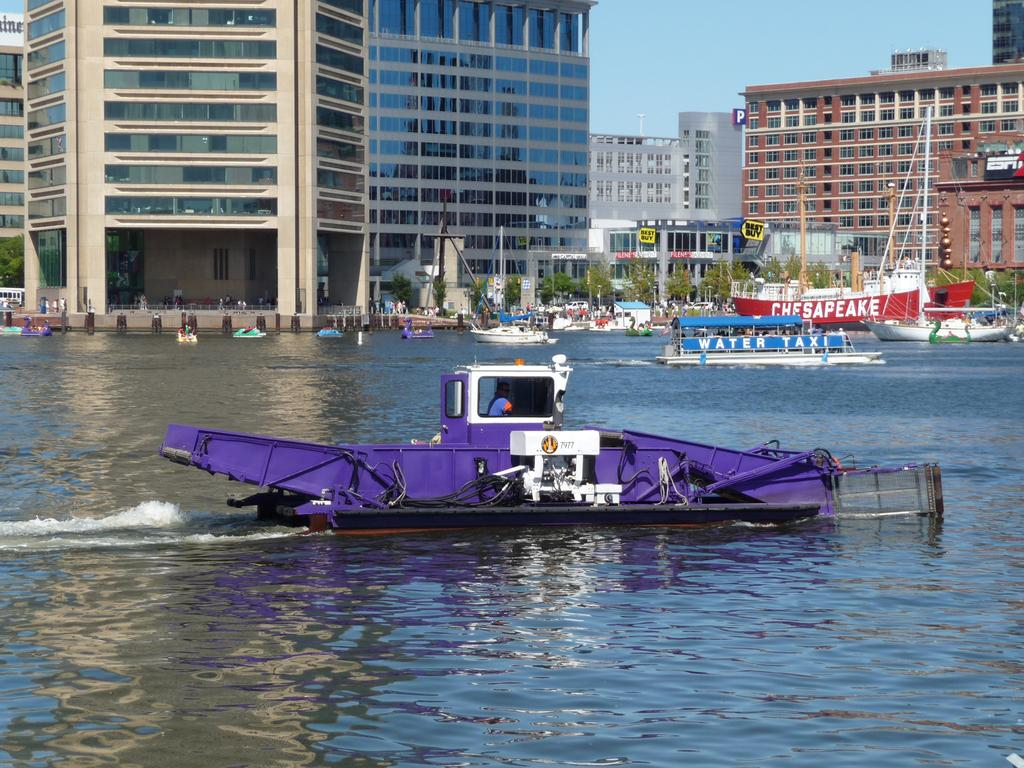What type of vehicles can be seen in the image? There are boats in the image. What is the primary element in which the boats are situated? There is water visible in the image. What type of natural vegetation is present in the image? There are trees in the image. What type of man-made structures can be seen in the image? There are buildings in the image. What is visible at the top of the image? The sky is visible at the top of the image. How many ladybugs can be seen on the boats in the image? There are no ladybugs present in the image; it features boats in the water with trees, buildings, and the sky visible. 